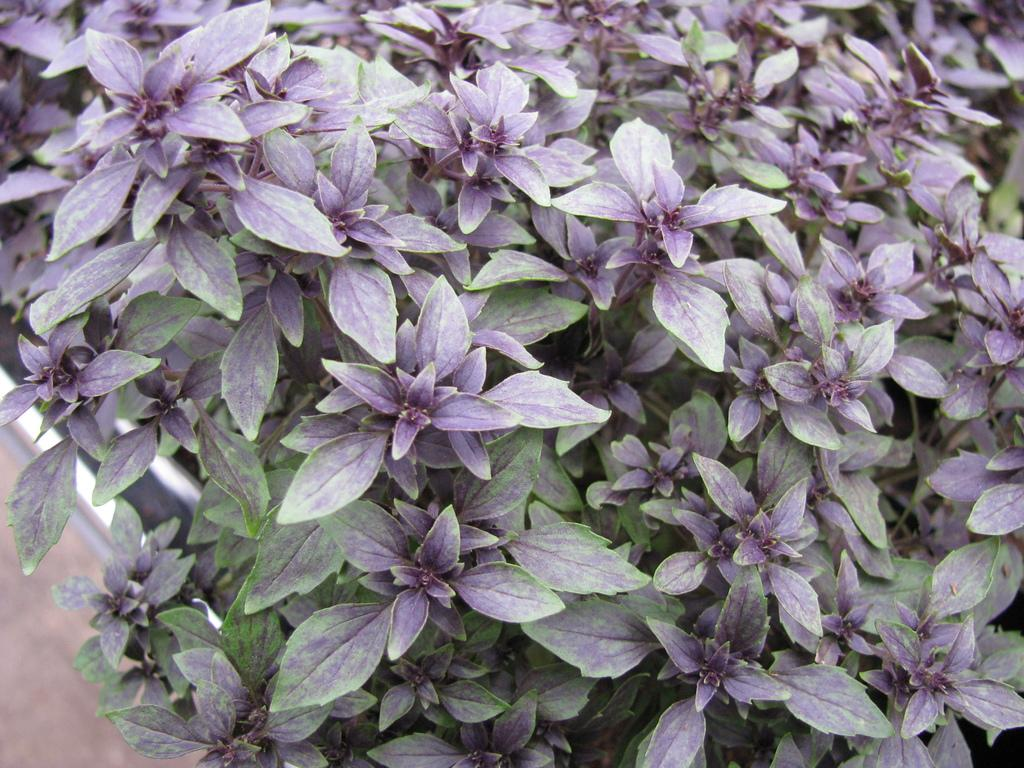What type of living organisms can be seen in the image? Flowers can be seen in the image. What type of mountain is visible in the background of the image? There is no mountain visible in the image; it only features flowers. What color is the sweater worn by the person in the image? There is no person or sweater present in the image, as it only features flowers. 